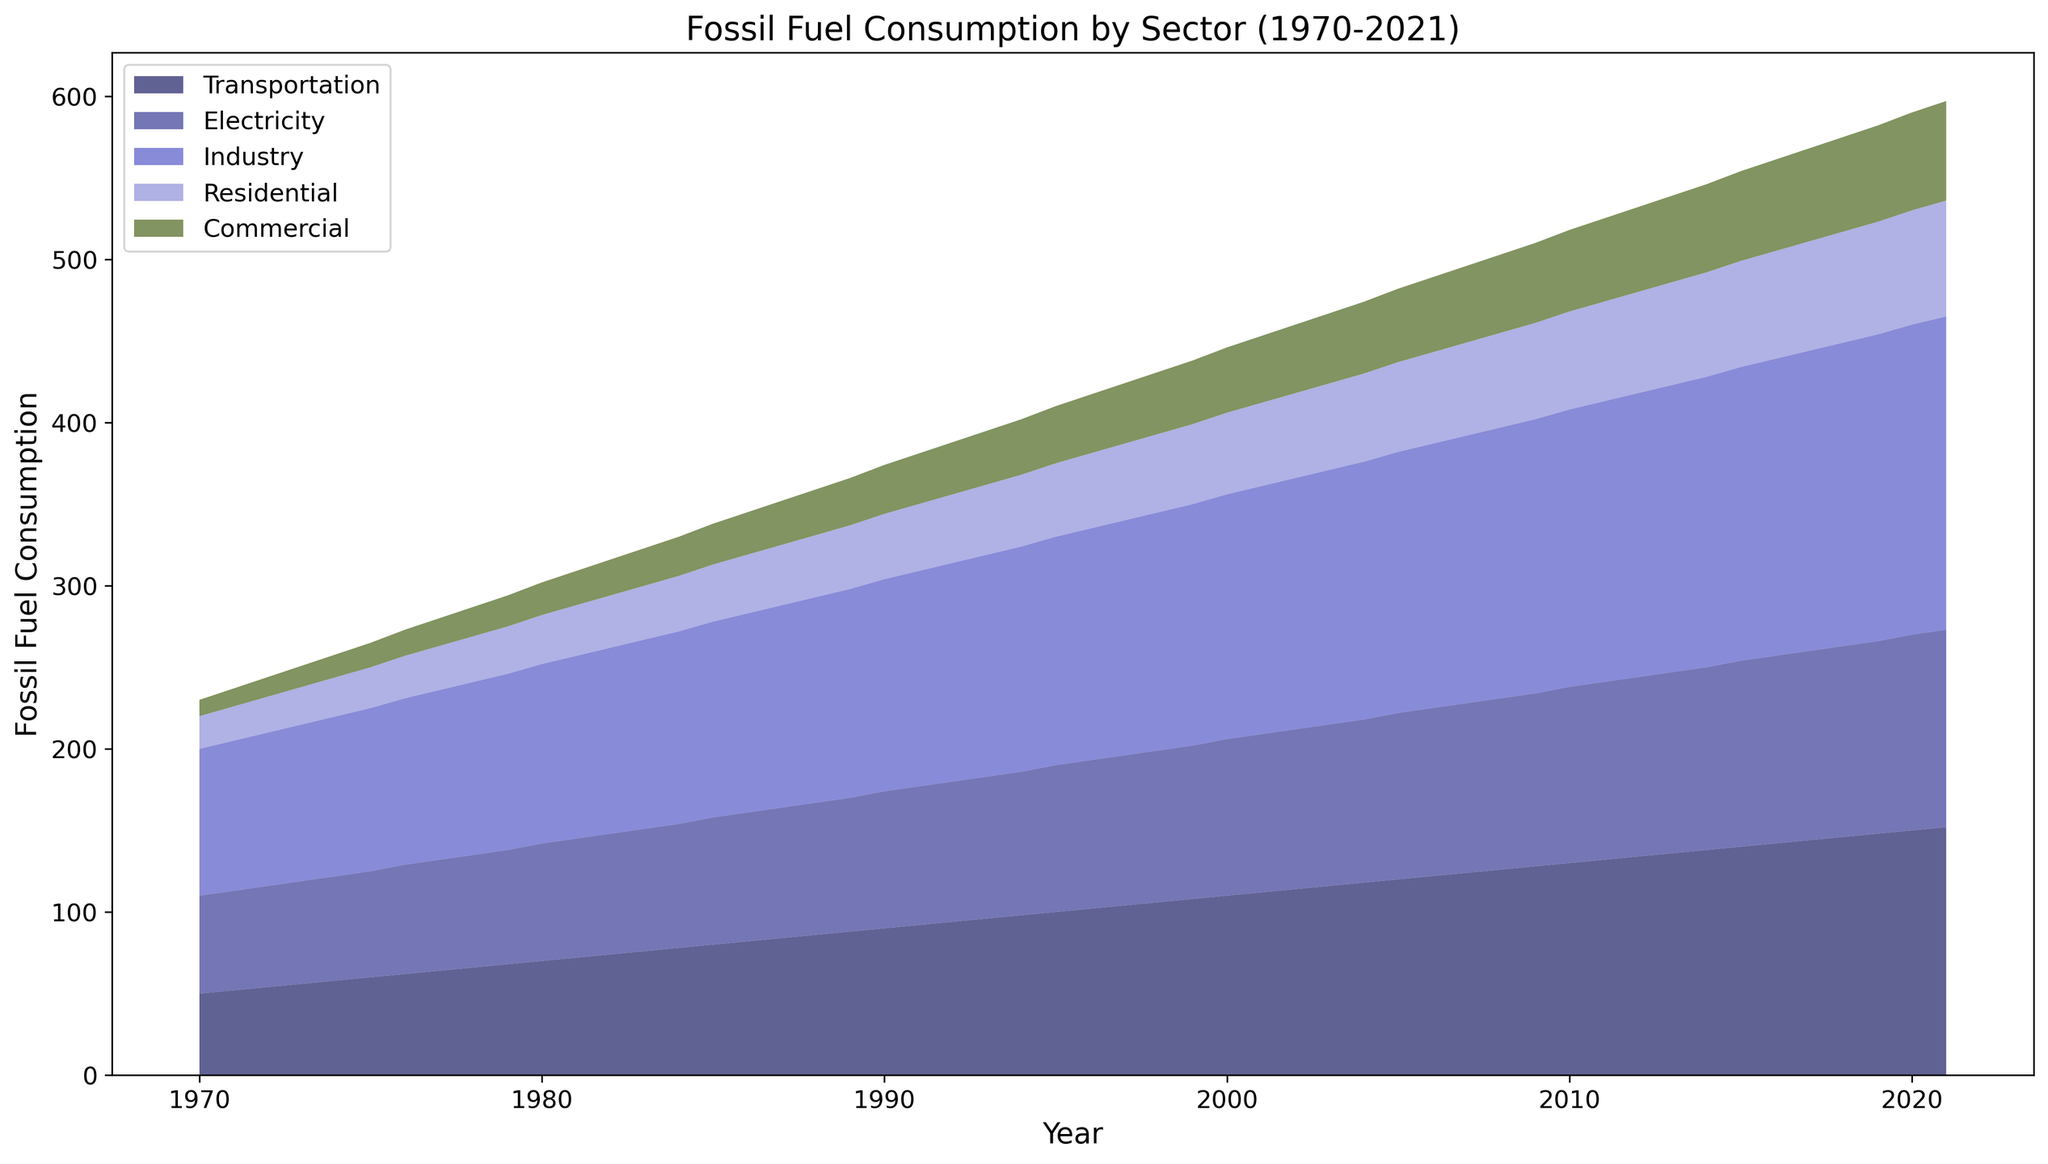What's the trend in fossil fuel consumption for the Transportation sector over the 50-year period? By looking at the graph, you can observe the Transportation sector's area. It consistently increases in height over years from 1970 to 2021. This indicates an upward trend.
Answer: Increasing Which sector shows the slowest growth in fossil fuel consumption over the period? Observing the graph, the areas for all five sectors increase, but the Commercial sector (green) shows the smallest area change from 1970 to 2021, indicating the slowest growth.
Answer: Commercial Which sector consumed the most fossil fuels in 2021? The height of the stacked area for each sector in 2021 can be compared. The Industry sector (light blue) has the largest height contribution at the end of the period.
Answer: Industry By how much has fossil fuel consumption in the Residential sector changed from 1970 to 2021? The height of the Residential sector area on the graph starts around 20 in 1970 and reaches around 70 in 2021. The difference between these values (70 - 20) gives the change.
Answer: 50 What year did the fossil fuel consumption for the Electricity sector surpass 100 units? Tracing the Electricity sector area, it crosses the 100 units mark around 2000.
Answer: 2000 How does the increase in the Commercial sector's consumption compare to the increase in the Transportation sector's consumption over the 50 years? In 1970, the Commercial sector started at 10 and ended at 61 in 2021, with an increase of 51 units. Transportation started at 50 in 1970 and ended at 152 in 2021, increasing by 102 units. Therefore, Transportation's increase is double that of Commercial.
Answer: Double What is the combined fossil fuel consumption of the Residential and Commercial sectors in 2021? The Residential sector consumed around 70 units, and the Commercial sector consumed around 61 units in 2021. Adding these values together gives 131 units.
Answer: 131 units What can be inferred about the period from the late 1970s to early 1980s for the Transportation and Electricity sectors? Observing the graph, the areas for both sectors are steepening during this period, indicating a rapid increase in fossil fuel consumption.
Answer: Rapid increase Is there any year where the consumption of the Residential sector exceeds the Commercial sector? By comparing the heights of each sector's area over the years, it is clear that in all years, the Residential sector's consumption is higher than the Commercial sector's.
Answer: Yes How does the consumption of the Electricity sector in 1980 compare to that in 2010? The height of the Electricity sector in 1980 is around 72 units, while in 2010 it is around 108 units. The difference (108 - 72) indicates an increase of 36 units.
Answer: Increase of 36 units 